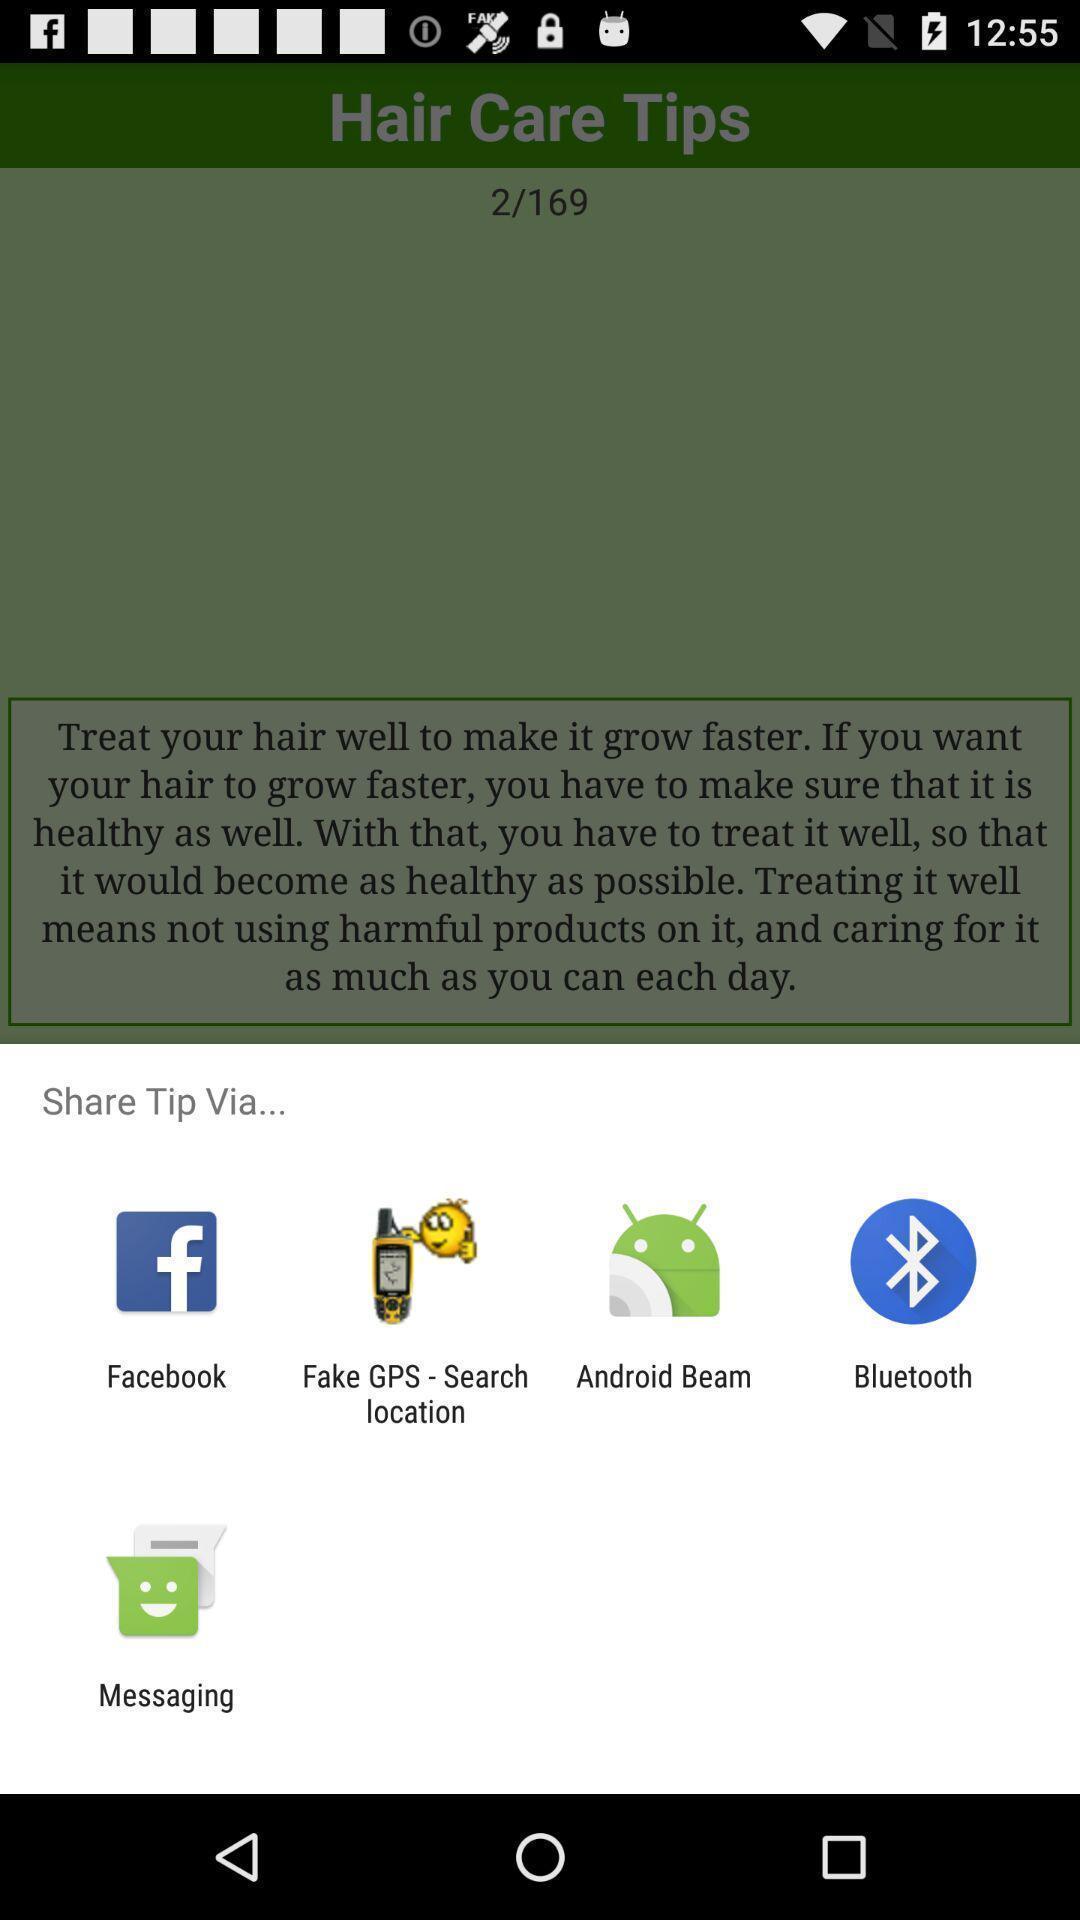What details can you identify in this image? Pop-up shows share tip with multiple applications. 